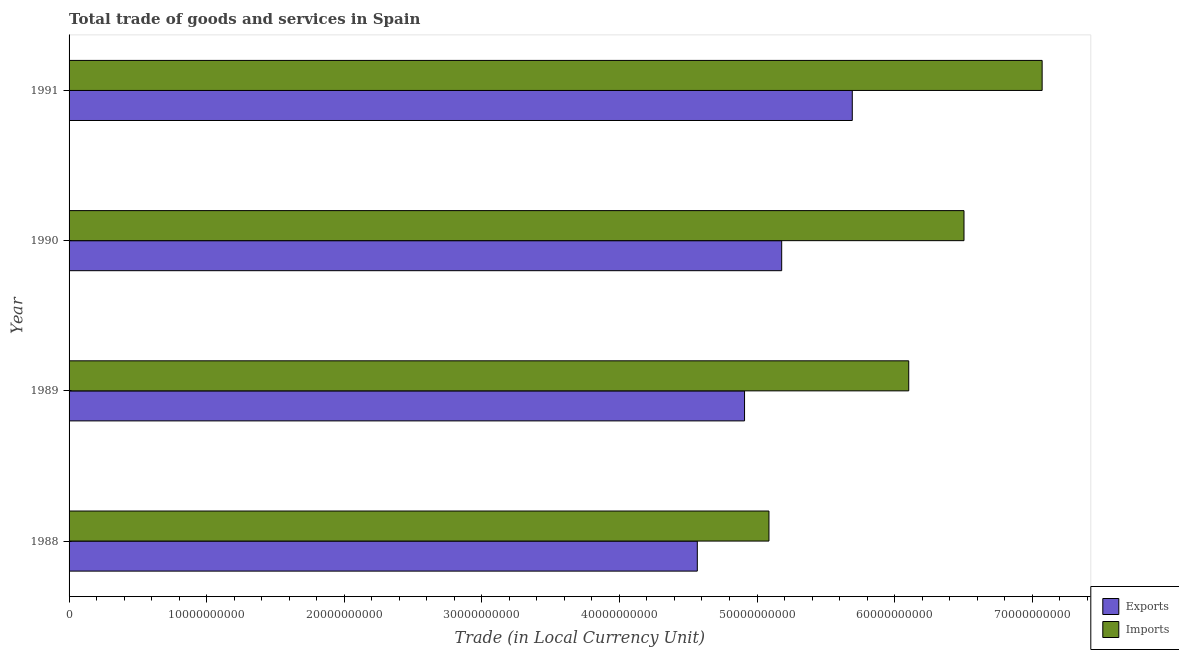How many different coloured bars are there?
Ensure brevity in your answer.  2. Are the number of bars per tick equal to the number of legend labels?
Your answer should be compact. Yes. What is the export of goods and services in 1990?
Offer a terse response. 5.18e+1. Across all years, what is the maximum export of goods and services?
Keep it short and to the point. 5.69e+1. Across all years, what is the minimum export of goods and services?
Offer a terse response. 4.57e+1. In which year was the export of goods and services maximum?
Make the answer very short. 1991. What is the total imports of goods and services in the graph?
Your response must be concise. 2.48e+11. What is the difference between the export of goods and services in 1988 and that in 1990?
Ensure brevity in your answer.  -6.13e+09. What is the difference between the export of goods and services in 1990 and the imports of goods and services in 1988?
Offer a terse response. 9.25e+08. What is the average imports of goods and services per year?
Your response must be concise. 6.19e+1. In the year 1991, what is the difference between the imports of goods and services and export of goods and services?
Offer a very short reply. 1.38e+1. What is the ratio of the imports of goods and services in 1989 to that in 1990?
Provide a succinct answer. 0.94. Is the export of goods and services in 1989 less than that in 1991?
Your response must be concise. Yes. What is the difference between the highest and the second highest imports of goods and services?
Make the answer very short. 5.68e+09. What is the difference between the highest and the lowest imports of goods and services?
Your response must be concise. 1.99e+1. Is the sum of the export of goods and services in 1988 and 1990 greater than the maximum imports of goods and services across all years?
Offer a terse response. Yes. What does the 2nd bar from the top in 1990 represents?
Keep it short and to the point. Exports. What does the 2nd bar from the bottom in 1990 represents?
Provide a succinct answer. Imports. How many bars are there?
Offer a very short reply. 8. What is the difference between two consecutive major ticks on the X-axis?
Provide a succinct answer. 1.00e+1. Where does the legend appear in the graph?
Provide a succinct answer. Bottom right. What is the title of the graph?
Offer a very short reply. Total trade of goods and services in Spain. What is the label or title of the X-axis?
Give a very brief answer. Trade (in Local Currency Unit). What is the label or title of the Y-axis?
Provide a short and direct response. Year. What is the Trade (in Local Currency Unit) in Exports in 1988?
Ensure brevity in your answer.  4.57e+1. What is the Trade (in Local Currency Unit) in Imports in 1988?
Ensure brevity in your answer.  5.09e+1. What is the Trade (in Local Currency Unit) of Exports in 1989?
Your answer should be very brief. 4.91e+1. What is the Trade (in Local Currency Unit) of Imports in 1989?
Your answer should be compact. 6.10e+1. What is the Trade (in Local Currency Unit) of Exports in 1990?
Make the answer very short. 5.18e+1. What is the Trade (in Local Currency Unit) of Imports in 1990?
Offer a terse response. 6.50e+1. What is the Trade (in Local Currency Unit) of Exports in 1991?
Your answer should be compact. 5.69e+1. What is the Trade (in Local Currency Unit) in Imports in 1991?
Your response must be concise. 7.07e+1. Across all years, what is the maximum Trade (in Local Currency Unit) of Exports?
Provide a short and direct response. 5.69e+1. Across all years, what is the maximum Trade (in Local Currency Unit) of Imports?
Your answer should be very brief. 7.07e+1. Across all years, what is the minimum Trade (in Local Currency Unit) of Exports?
Offer a very short reply. 4.57e+1. Across all years, what is the minimum Trade (in Local Currency Unit) in Imports?
Provide a short and direct response. 5.09e+1. What is the total Trade (in Local Currency Unit) in Exports in the graph?
Your response must be concise. 2.03e+11. What is the total Trade (in Local Currency Unit) in Imports in the graph?
Offer a very short reply. 2.48e+11. What is the difference between the Trade (in Local Currency Unit) in Exports in 1988 and that in 1989?
Ensure brevity in your answer.  -3.43e+09. What is the difference between the Trade (in Local Currency Unit) in Imports in 1988 and that in 1989?
Offer a very short reply. -1.02e+1. What is the difference between the Trade (in Local Currency Unit) in Exports in 1988 and that in 1990?
Offer a very short reply. -6.13e+09. What is the difference between the Trade (in Local Currency Unit) of Imports in 1988 and that in 1990?
Your answer should be very brief. -1.42e+1. What is the difference between the Trade (in Local Currency Unit) in Exports in 1988 and that in 1991?
Keep it short and to the point. -1.13e+1. What is the difference between the Trade (in Local Currency Unit) of Imports in 1988 and that in 1991?
Your answer should be compact. -1.99e+1. What is the difference between the Trade (in Local Currency Unit) of Exports in 1989 and that in 1990?
Your response must be concise. -2.70e+09. What is the difference between the Trade (in Local Currency Unit) in Imports in 1989 and that in 1990?
Offer a very short reply. -4.02e+09. What is the difference between the Trade (in Local Currency Unit) in Exports in 1989 and that in 1991?
Keep it short and to the point. -7.83e+09. What is the difference between the Trade (in Local Currency Unit) in Imports in 1989 and that in 1991?
Give a very brief answer. -9.70e+09. What is the difference between the Trade (in Local Currency Unit) in Exports in 1990 and that in 1991?
Provide a short and direct response. -5.13e+09. What is the difference between the Trade (in Local Currency Unit) of Imports in 1990 and that in 1991?
Your response must be concise. -5.68e+09. What is the difference between the Trade (in Local Currency Unit) of Exports in 1988 and the Trade (in Local Currency Unit) of Imports in 1989?
Offer a terse response. -1.54e+1. What is the difference between the Trade (in Local Currency Unit) of Exports in 1988 and the Trade (in Local Currency Unit) of Imports in 1990?
Your response must be concise. -1.94e+1. What is the difference between the Trade (in Local Currency Unit) in Exports in 1988 and the Trade (in Local Currency Unit) in Imports in 1991?
Ensure brevity in your answer.  -2.51e+1. What is the difference between the Trade (in Local Currency Unit) in Exports in 1989 and the Trade (in Local Currency Unit) in Imports in 1990?
Your answer should be very brief. -1.60e+1. What is the difference between the Trade (in Local Currency Unit) of Exports in 1989 and the Trade (in Local Currency Unit) of Imports in 1991?
Offer a very short reply. -2.16e+1. What is the difference between the Trade (in Local Currency Unit) of Exports in 1990 and the Trade (in Local Currency Unit) of Imports in 1991?
Your answer should be very brief. -1.89e+1. What is the average Trade (in Local Currency Unit) in Exports per year?
Make the answer very short. 5.09e+1. What is the average Trade (in Local Currency Unit) of Imports per year?
Offer a terse response. 6.19e+1. In the year 1988, what is the difference between the Trade (in Local Currency Unit) in Exports and Trade (in Local Currency Unit) in Imports?
Offer a terse response. -5.21e+09. In the year 1989, what is the difference between the Trade (in Local Currency Unit) in Exports and Trade (in Local Currency Unit) in Imports?
Offer a very short reply. -1.19e+1. In the year 1990, what is the difference between the Trade (in Local Currency Unit) in Exports and Trade (in Local Currency Unit) in Imports?
Provide a short and direct response. -1.33e+1. In the year 1991, what is the difference between the Trade (in Local Currency Unit) of Exports and Trade (in Local Currency Unit) of Imports?
Give a very brief answer. -1.38e+1. What is the ratio of the Trade (in Local Currency Unit) of Exports in 1988 to that in 1989?
Make the answer very short. 0.93. What is the ratio of the Trade (in Local Currency Unit) of Imports in 1988 to that in 1989?
Your response must be concise. 0.83. What is the ratio of the Trade (in Local Currency Unit) of Exports in 1988 to that in 1990?
Provide a short and direct response. 0.88. What is the ratio of the Trade (in Local Currency Unit) of Imports in 1988 to that in 1990?
Ensure brevity in your answer.  0.78. What is the ratio of the Trade (in Local Currency Unit) in Exports in 1988 to that in 1991?
Give a very brief answer. 0.8. What is the ratio of the Trade (in Local Currency Unit) in Imports in 1988 to that in 1991?
Provide a succinct answer. 0.72. What is the ratio of the Trade (in Local Currency Unit) in Exports in 1989 to that in 1990?
Your answer should be very brief. 0.95. What is the ratio of the Trade (in Local Currency Unit) of Imports in 1989 to that in 1990?
Provide a succinct answer. 0.94. What is the ratio of the Trade (in Local Currency Unit) in Exports in 1989 to that in 1991?
Make the answer very short. 0.86. What is the ratio of the Trade (in Local Currency Unit) of Imports in 1989 to that in 1991?
Give a very brief answer. 0.86. What is the ratio of the Trade (in Local Currency Unit) in Exports in 1990 to that in 1991?
Offer a terse response. 0.91. What is the ratio of the Trade (in Local Currency Unit) in Imports in 1990 to that in 1991?
Keep it short and to the point. 0.92. What is the difference between the highest and the second highest Trade (in Local Currency Unit) of Exports?
Provide a short and direct response. 5.13e+09. What is the difference between the highest and the second highest Trade (in Local Currency Unit) of Imports?
Ensure brevity in your answer.  5.68e+09. What is the difference between the highest and the lowest Trade (in Local Currency Unit) of Exports?
Offer a very short reply. 1.13e+1. What is the difference between the highest and the lowest Trade (in Local Currency Unit) in Imports?
Keep it short and to the point. 1.99e+1. 